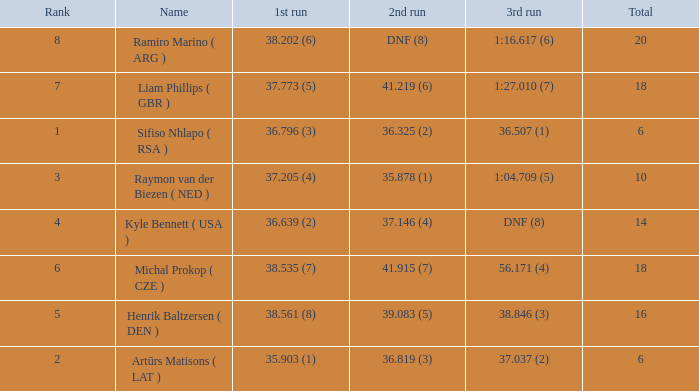Which average rank has a total of 16? 5.0. 